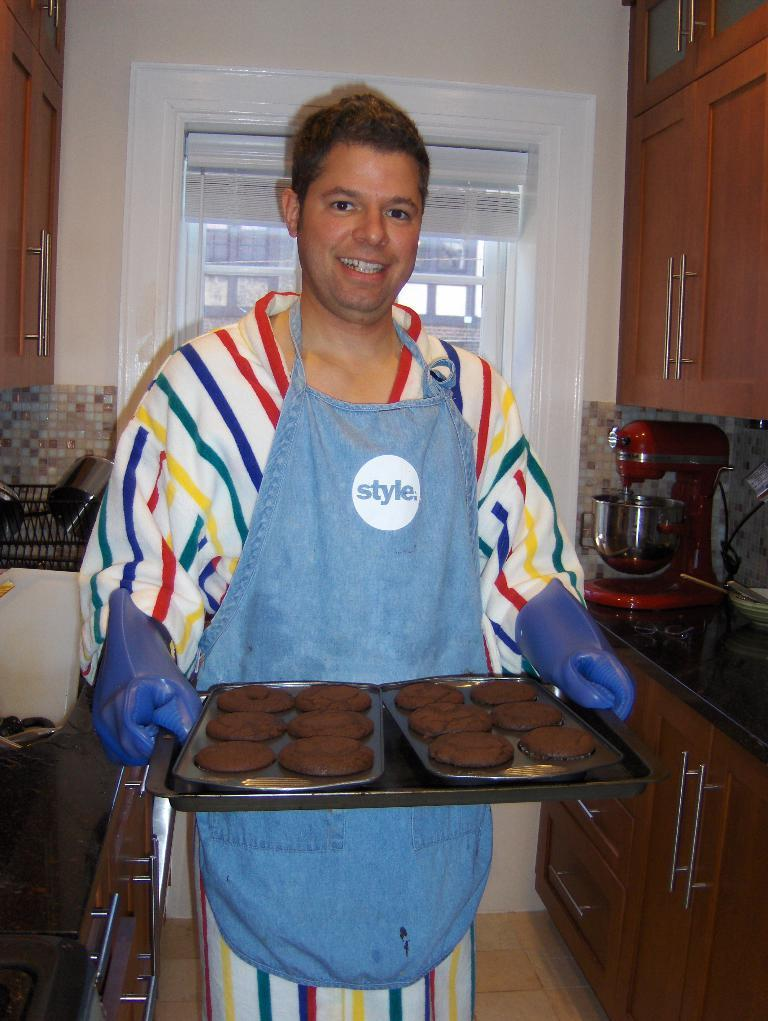Provide a one-sentence caption for the provided image. Man holding some cookies while wearing an apron that says Style. 